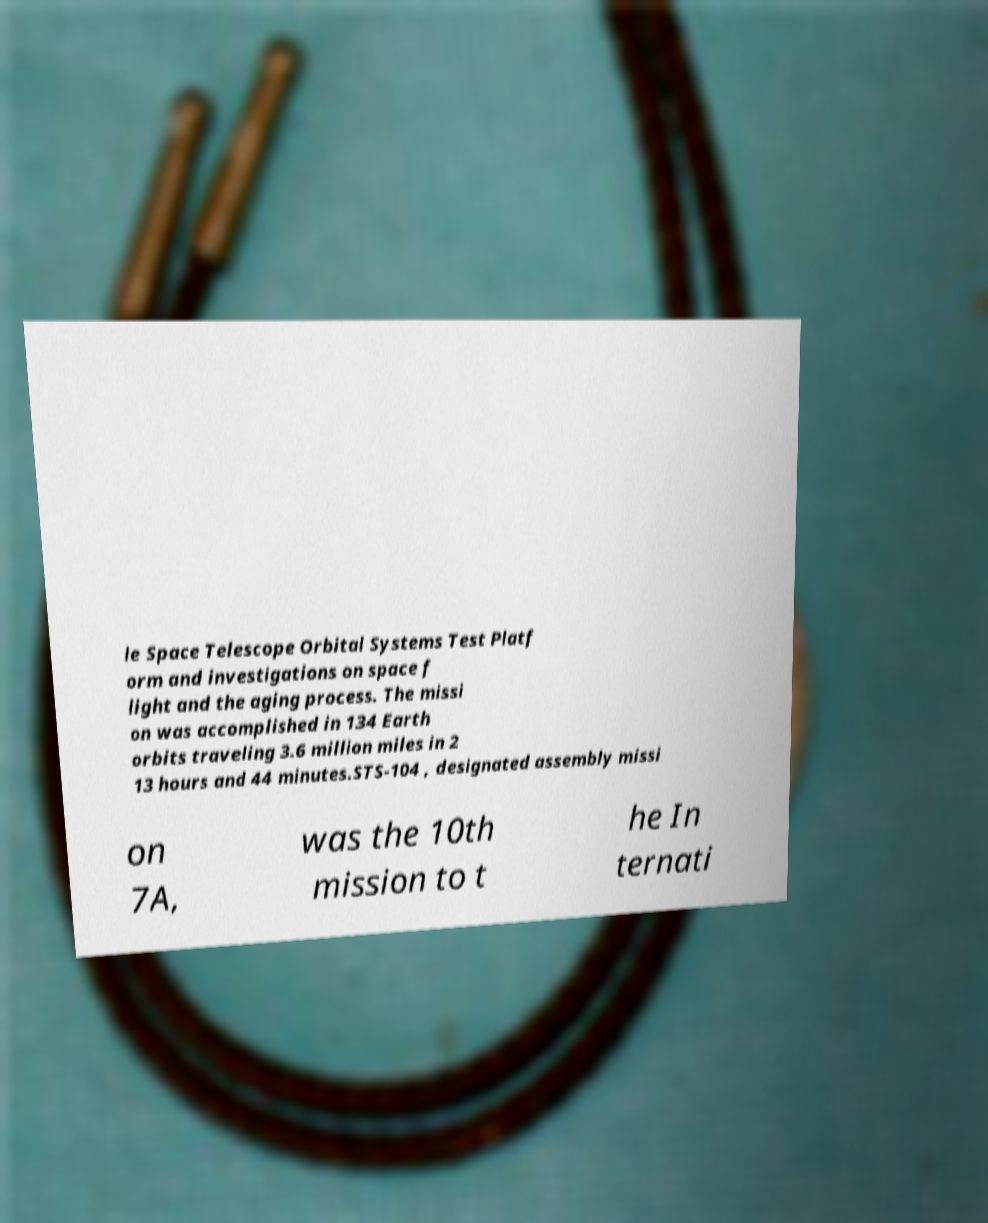Please read and relay the text visible in this image. What does it say? le Space Telescope Orbital Systems Test Platf orm and investigations on space f light and the aging process. The missi on was accomplished in 134 Earth orbits traveling 3.6 million miles in 2 13 hours and 44 minutes.STS-104 , designated assembly missi on 7A, was the 10th mission to t he In ternati 